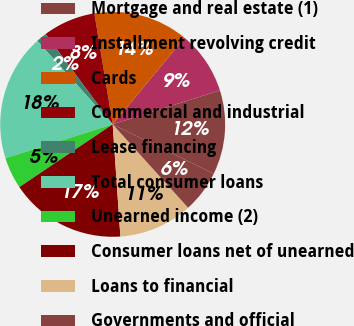Convert chart to OTSL. <chart><loc_0><loc_0><loc_500><loc_500><pie_chart><fcel>Mortgage and real estate (1)<fcel>Installment revolving credit<fcel>Cards<fcel>Commercial and industrial<fcel>Lease financing<fcel>Total consumer loans<fcel>Unearned income (2)<fcel>Consumer loans net of unearned<fcel>Loans to financial<fcel>Governments and official<nl><fcel>12.12%<fcel>9.09%<fcel>13.64%<fcel>7.58%<fcel>1.52%<fcel>18.18%<fcel>4.55%<fcel>16.67%<fcel>10.61%<fcel>6.06%<nl></chart> 